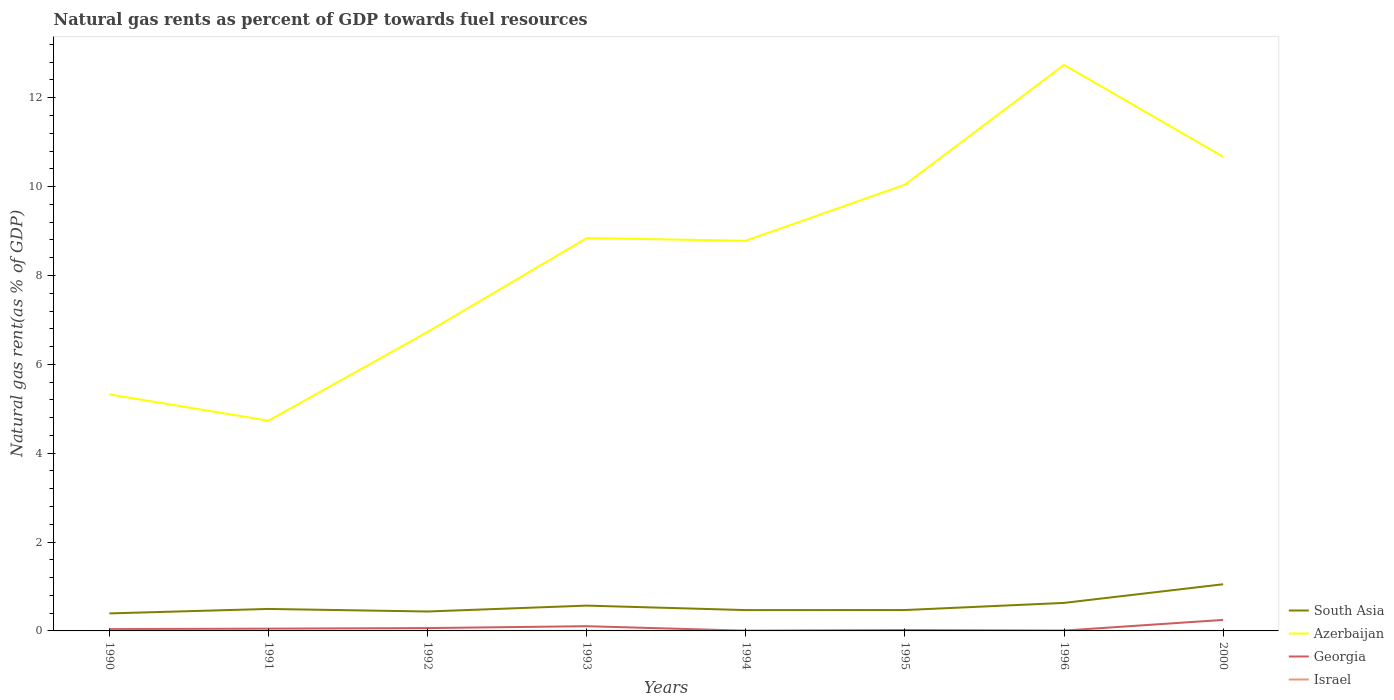How many different coloured lines are there?
Give a very brief answer. 4. Is the number of lines equal to the number of legend labels?
Keep it short and to the point. Yes. Across all years, what is the maximum natural gas rent in Georgia?
Provide a short and direct response. 0.01. In which year was the natural gas rent in Azerbaijan maximum?
Provide a succinct answer. 1991. What is the total natural gas rent in Azerbaijan in the graph?
Provide a short and direct response. -6.01. What is the difference between the highest and the second highest natural gas rent in Azerbaijan?
Ensure brevity in your answer.  8.01. What is the difference between the highest and the lowest natural gas rent in South Asia?
Your answer should be compact. 3. Is the natural gas rent in Georgia strictly greater than the natural gas rent in Azerbaijan over the years?
Offer a very short reply. Yes. How many lines are there?
Offer a terse response. 4. How many years are there in the graph?
Make the answer very short. 8. Where does the legend appear in the graph?
Offer a very short reply. Bottom right. What is the title of the graph?
Your answer should be compact. Natural gas rents as percent of GDP towards fuel resources. Does "Finland" appear as one of the legend labels in the graph?
Your response must be concise. No. What is the label or title of the X-axis?
Ensure brevity in your answer.  Years. What is the label or title of the Y-axis?
Provide a succinct answer. Natural gas rent(as % of GDP). What is the Natural gas rent(as % of GDP) in South Asia in 1990?
Your answer should be compact. 0.39. What is the Natural gas rent(as % of GDP) in Azerbaijan in 1990?
Keep it short and to the point. 5.32. What is the Natural gas rent(as % of GDP) of Georgia in 1990?
Give a very brief answer. 0.04. What is the Natural gas rent(as % of GDP) of Israel in 1990?
Your response must be concise. 0. What is the Natural gas rent(as % of GDP) of South Asia in 1991?
Provide a short and direct response. 0.49. What is the Natural gas rent(as % of GDP) in Azerbaijan in 1991?
Provide a short and direct response. 4.73. What is the Natural gas rent(as % of GDP) of Georgia in 1991?
Offer a very short reply. 0.05. What is the Natural gas rent(as % of GDP) of Israel in 1991?
Provide a short and direct response. 0. What is the Natural gas rent(as % of GDP) in South Asia in 1992?
Give a very brief answer. 0.44. What is the Natural gas rent(as % of GDP) of Azerbaijan in 1992?
Your response must be concise. 6.73. What is the Natural gas rent(as % of GDP) in Georgia in 1992?
Offer a very short reply. 0.06. What is the Natural gas rent(as % of GDP) in Israel in 1992?
Keep it short and to the point. 0. What is the Natural gas rent(as % of GDP) in South Asia in 1993?
Give a very brief answer. 0.57. What is the Natural gas rent(as % of GDP) in Azerbaijan in 1993?
Your answer should be very brief. 8.84. What is the Natural gas rent(as % of GDP) of Georgia in 1993?
Provide a succinct answer. 0.11. What is the Natural gas rent(as % of GDP) in Israel in 1993?
Give a very brief answer. 0. What is the Natural gas rent(as % of GDP) of South Asia in 1994?
Provide a short and direct response. 0.47. What is the Natural gas rent(as % of GDP) of Azerbaijan in 1994?
Provide a short and direct response. 8.78. What is the Natural gas rent(as % of GDP) of Georgia in 1994?
Provide a succinct answer. 0.01. What is the Natural gas rent(as % of GDP) of Israel in 1994?
Provide a short and direct response. 0. What is the Natural gas rent(as % of GDP) in South Asia in 1995?
Your answer should be compact. 0.47. What is the Natural gas rent(as % of GDP) in Azerbaijan in 1995?
Your response must be concise. 10.04. What is the Natural gas rent(as % of GDP) in Georgia in 1995?
Your answer should be compact. 0.02. What is the Natural gas rent(as % of GDP) of Israel in 1995?
Provide a succinct answer. 0. What is the Natural gas rent(as % of GDP) in South Asia in 1996?
Make the answer very short. 0.63. What is the Natural gas rent(as % of GDP) in Azerbaijan in 1996?
Provide a succinct answer. 12.74. What is the Natural gas rent(as % of GDP) in Georgia in 1996?
Make the answer very short. 0.01. What is the Natural gas rent(as % of GDP) of Israel in 1996?
Provide a short and direct response. 0. What is the Natural gas rent(as % of GDP) of South Asia in 2000?
Give a very brief answer. 1.05. What is the Natural gas rent(as % of GDP) in Azerbaijan in 2000?
Ensure brevity in your answer.  10.67. What is the Natural gas rent(as % of GDP) of Georgia in 2000?
Ensure brevity in your answer.  0.25. What is the Natural gas rent(as % of GDP) in Israel in 2000?
Your answer should be very brief. 0. Across all years, what is the maximum Natural gas rent(as % of GDP) of South Asia?
Give a very brief answer. 1.05. Across all years, what is the maximum Natural gas rent(as % of GDP) in Azerbaijan?
Make the answer very short. 12.74. Across all years, what is the maximum Natural gas rent(as % of GDP) of Georgia?
Offer a terse response. 0.25. Across all years, what is the maximum Natural gas rent(as % of GDP) in Israel?
Provide a short and direct response. 0. Across all years, what is the minimum Natural gas rent(as % of GDP) of South Asia?
Offer a terse response. 0.39. Across all years, what is the minimum Natural gas rent(as % of GDP) of Azerbaijan?
Offer a very short reply. 4.73. Across all years, what is the minimum Natural gas rent(as % of GDP) in Georgia?
Give a very brief answer. 0.01. Across all years, what is the minimum Natural gas rent(as % of GDP) of Israel?
Ensure brevity in your answer.  0. What is the total Natural gas rent(as % of GDP) in South Asia in the graph?
Make the answer very short. 4.52. What is the total Natural gas rent(as % of GDP) of Azerbaijan in the graph?
Ensure brevity in your answer.  67.86. What is the total Natural gas rent(as % of GDP) in Georgia in the graph?
Provide a succinct answer. 0.54. What is the total Natural gas rent(as % of GDP) in Israel in the graph?
Keep it short and to the point. 0.02. What is the difference between the Natural gas rent(as % of GDP) of South Asia in 1990 and that in 1991?
Offer a very short reply. -0.1. What is the difference between the Natural gas rent(as % of GDP) in Azerbaijan in 1990 and that in 1991?
Your answer should be compact. 0.59. What is the difference between the Natural gas rent(as % of GDP) in Georgia in 1990 and that in 1991?
Give a very brief answer. -0.01. What is the difference between the Natural gas rent(as % of GDP) in Israel in 1990 and that in 1991?
Keep it short and to the point. 0. What is the difference between the Natural gas rent(as % of GDP) of South Asia in 1990 and that in 1992?
Your answer should be very brief. -0.04. What is the difference between the Natural gas rent(as % of GDP) of Azerbaijan in 1990 and that in 1992?
Give a very brief answer. -1.41. What is the difference between the Natural gas rent(as % of GDP) in Georgia in 1990 and that in 1992?
Provide a succinct answer. -0.02. What is the difference between the Natural gas rent(as % of GDP) in Israel in 1990 and that in 1992?
Provide a short and direct response. 0. What is the difference between the Natural gas rent(as % of GDP) of South Asia in 1990 and that in 1993?
Give a very brief answer. -0.18. What is the difference between the Natural gas rent(as % of GDP) in Azerbaijan in 1990 and that in 1993?
Provide a short and direct response. -3.52. What is the difference between the Natural gas rent(as % of GDP) in Georgia in 1990 and that in 1993?
Offer a very short reply. -0.07. What is the difference between the Natural gas rent(as % of GDP) of Israel in 1990 and that in 1993?
Your answer should be very brief. 0. What is the difference between the Natural gas rent(as % of GDP) of South Asia in 1990 and that in 1994?
Your answer should be very brief. -0.07. What is the difference between the Natural gas rent(as % of GDP) of Azerbaijan in 1990 and that in 1994?
Provide a succinct answer. -3.46. What is the difference between the Natural gas rent(as % of GDP) of Georgia in 1990 and that in 1994?
Your response must be concise. 0.04. What is the difference between the Natural gas rent(as % of GDP) in Israel in 1990 and that in 1994?
Give a very brief answer. 0. What is the difference between the Natural gas rent(as % of GDP) in South Asia in 1990 and that in 1995?
Your response must be concise. -0.08. What is the difference between the Natural gas rent(as % of GDP) in Azerbaijan in 1990 and that in 1995?
Your answer should be very brief. -4.72. What is the difference between the Natural gas rent(as % of GDP) of Georgia in 1990 and that in 1995?
Provide a succinct answer. 0.02. What is the difference between the Natural gas rent(as % of GDP) in Israel in 1990 and that in 1995?
Your answer should be very brief. 0. What is the difference between the Natural gas rent(as % of GDP) in South Asia in 1990 and that in 1996?
Give a very brief answer. -0.24. What is the difference between the Natural gas rent(as % of GDP) in Azerbaijan in 1990 and that in 1996?
Your answer should be compact. -7.42. What is the difference between the Natural gas rent(as % of GDP) in Georgia in 1990 and that in 1996?
Provide a short and direct response. 0.03. What is the difference between the Natural gas rent(as % of GDP) in Israel in 1990 and that in 1996?
Ensure brevity in your answer.  0. What is the difference between the Natural gas rent(as % of GDP) in South Asia in 1990 and that in 2000?
Make the answer very short. -0.66. What is the difference between the Natural gas rent(as % of GDP) of Azerbaijan in 1990 and that in 2000?
Offer a very short reply. -5.35. What is the difference between the Natural gas rent(as % of GDP) in Georgia in 1990 and that in 2000?
Keep it short and to the point. -0.21. What is the difference between the Natural gas rent(as % of GDP) in Israel in 1990 and that in 2000?
Your answer should be compact. 0. What is the difference between the Natural gas rent(as % of GDP) in South Asia in 1991 and that in 1992?
Ensure brevity in your answer.  0.06. What is the difference between the Natural gas rent(as % of GDP) of Azerbaijan in 1991 and that in 1992?
Ensure brevity in your answer.  -2. What is the difference between the Natural gas rent(as % of GDP) of Georgia in 1991 and that in 1992?
Your response must be concise. -0.01. What is the difference between the Natural gas rent(as % of GDP) of Israel in 1991 and that in 1992?
Your response must be concise. 0. What is the difference between the Natural gas rent(as % of GDP) of South Asia in 1991 and that in 1993?
Your answer should be compact. -0.07. What is the difference between the Natural gas rent(as % of GDP) in Azerbaijan in 1991 and that in 1993?
Offer a terse response. -4.11. What is the difference between the Natural gas rent(as % of GDP) of Georgia in 1991 and that in 1993?
Offer a terse response. -0.06. What is the difference between the Natural gas rent(as % of GDP) of South Asia in 1991 and that in 1994?
Provide a short and direct response. 0.03. What is the difference between the Natural gas rent(as % of GDP) in Azerbaijan in 1991 and that in 1994?
Provide a succinct answer. -4.05. What is the difference between the Natural gas rent(as % of GDP) in Georgia in 1991 and that in 1994?
Provide a succinct answer. 0.05. What is the difference between the Natural gas rent(as % of GDP) in Israel in 1991 and that in 1994?
Offer a terse response. 0. What is the difference between the Natural gas rent(as % of GDP) in South Asia in 1991 and that in 1995?
Your answer should be compact. 0.02. What is the difference between the Natural gas rent(as % of GDP) of Azerbaijan in 1991 and that in 1995?
Provide a succinct answer. -5.31. What is the difference between the Natural gas rent(as % of GDP) of Georgia in 1991 and that in 1995?
Keep it short and to the point. 0.03. What is the difference between the Natural gas rent(as % of GDP) of Israel in 1991 and that in 1995?
Provide a succinct answer. 0. What is the difference between the Natural gas rent(as % of GDP) of South Asia in 1991 and that in 1996?
Your answer should be very brief. -0.14. What is the difference between the Natural gas rent(as % of GDP) in Azerbaijan in 1991 and that in 1996?
Your answer should be very brief. -8.01. What is the difference between the Natural gas rent(as % of GDP) in Georgia in 1991 and that in 1996?
Ensure brevity in your answer.  0.04. What is the difference between the Natural gas rent(as % of GDP) of Israel in 1991 and that in 1996?
Offer a very short reply. 0. What is the difference between the Natural gas rent(as % of GDP) in South Asia in 1991 and that in 2000?
Provide a succinct answer. -0.56. What is the difference between the Natural gas rent(as % of GDP) of Azerbaijan in 1991 and that in 2000?
Make the answer very short. -5.94. What is the difference between the Natural gas rent(as % of GDP) in Georgia in 1991 and that in 2000?
Your answer should be compact. -0.2. What is the difference between the Natural gas rent(as % of GDP) of Israel in 1991 and that in 2000?
Give a very brief answer. 0. What is the difference between the Natural gas rent(as % of GDP) in South Asia in 1992 and that in 1993?
Offer a very short reply. -0.13. What is the difference between the Natural gas rent(as % of GDP) of Azerbaijan in 1992 and that in 1993?
Keep it short and to the point. -2.11. What is the difference between the Natural gas rent(as % of GDP) of Georgia in 1992 and that in 1993?
Keep it short and to the point. -0.04. What is the difference between the Natural gas rent(as % of GDP) in Israel in 1992 and that in 1993?
Your answer should be very brief. -0. What is the difference between the Natural gas rent(as % of GDP) in South Asia in 1992 and that in 1994?
Ensure brevity in your answer.  -0.03. What is the difference between the Natural gas rent(as % of GDP) of Azerbaijan in 1992 and that in 1994?
Provide a short and direct response. -2.05. What is the difference between the Natural gas rent(as % of GDP) of Georgia in 1992 and that in 1994?
Make the answer very short. 0.06. What is the difference between the Natural gas rent(as % of GDP) of South Asia in 1992 and that in 1995?
Your response must be concise. -0.03. What is the difference between the Natural gas rent(as % of GDP) in Azerbaijan in 1992 and that in 1995?
Offer a very short reply. -3.31. What is the difference between the Natural gas rent(as % of GDP) of Georgia in 1992 and that in 1995?
Ensure brevity in your answer.  0.04. What is the difference between the Natural gas rent(as % of GDP) in Israel in 1992 and that in 1995?
Offer a very short reply. 0. What is the difference between the Natural gas rent(as % of GDP) of South Asia in 1992 and that in 1996?
Make the answer very short. -0.19. What is the difference between the Natural gas rent(as % of GDP) in Azerbaijan in 1992 and that in 1996?
Provide a short and direct response. -6.01. What is the difference between the Natural gas rent(as % of GDP) in Georgia in 1992 and that in 1996?
Provide a succinct answer. 0.06. What is the difference between the Natural gas rent(as % of GDP) in South Asia in 1992 and that in 2000?
Your answer should be very brief. -0.61. What is the difference between the Natural gas rent(as % of GDP) in Azerbaijan in 1992 and that in 2000?
Give a very brief answer. -3.94. What is the difference between the Natural gas rent(as % of GDP) of Georgia in 1992 and that in 2000?
Keep it short and to the point. -0.18. What is the difference between the Natural gas rent(as % of GDP) in Israel in 1992 and that in 2000?
Offer a terse response. 0. What is the difference between the Natural gas rent(as % of GDP) of South Asia in 1993 and that in 1994?
Provide a short and direct response. 0.1. What is the difference between the Natural gas rent(as % of GDP) of Azerbaijan in 1993 and that in 1994?
Provide a short and direct response. 0.06. What is the difference between the Natural gas rent(as % of GDP) in Georgia in 1993 and that in 1994?
Make the answer very short. 0.1. What is the difference between the Natural gas rent(as % of GDP) of Israel in 1993 and that in 1994?
Provide a short and direct response. 0. What is the difference between the Natural gas rent(as % of GDP) of South Asia in 1993 and that in 1995?
Ensure brevity in your answer.  0.1. What is the difference between the Natural gas rent(as % of GDP) of Azerbaijan in 1993 and that in 1995?
Offer a terse response. -1.2. What is the difference between the Natural gas rent(as % of GDP) in Georgia in 1993 and that in 1995?
Your response must be concise. 0.09. What is the difference between the Natural gas rent(as % of GDP) in Israel in 1993 and that in 1995?
Your answer should be compact. 0. What is the difference between the Natural gas rent(as % of GDP) of South Asia in 1993 and that in 1996?
Offer a very short reply. -0.06. What is the difference between the Natural gas rent(as % of GDP) in Azerbaijan in 1993 and that in 1996?
Offer a terse response. -3.9. What is the difference between the Natural gas rent(as % of GDP) of Georgia in 1993 and that in 1996?
Provide a succinct answer. 0.1. What is the difference between the Natural gas rent(as % of GDP) of Israel in 1993 and that in 1996?
Offer a terse response. 0. What is the difference between the Natural gas rent(as % of GDP) in South Asia in 1993 and that in 2000?
Ensure brevity in your answer.  -0.48. What is the difference between the Natural gas rent(as % of GDP) of Azerbaijan in 1993 and that in 2000?
Offer a terse response. -1.83. What is the difference between the Natural gas rent(as % of GDP) in Georgia in 1993 and that in 2000?
Make the answer very short. -0.14. What is the difference between the Natural gas rent(as % of GDP) of Israel in 1993 and that in 2000?
Give a very brief answer. 0. What is the difference between the Natural gas rent(as % of GDP) of South Asia in 1994 and that in 1995?
Your answer should be very brief. -0. What is the difference between the Natural gas rent(as % of GDP) in Azerbaijan in 1994 and that in 1995?
Make the answer very short. -1.26. What is the difference between the Natural gas rent(as % of GDP) of Georgia in 1994 and that in 1995?
Your response must be concise. -0.01. What is the difference between the Natural gas rent(as % of GDP) in South Asia in 1994 and that in 1996?
Give a very brief answer. -0.16. What is the difference between the Natural gas rent(as % of GDP) in Azerbaijan in 1994 and that in 1996?
Give a very brief answer. -3.96. What is the difference between the Natural gas rent(as % of GDP) of Georgia in 1994 and that in 1996?
Provide a succinct answer. -0. What is the difference between the Natural gas rent(as % of GDP) of Israel in 1994 and that in 1996?
Give a very brief answer. 0. What is the difference between the Natural gas rent(as % of GDP) of South Asia in 1994 and that in 2000?
Make the answer very short. -0.58. What is the difference between the Natural gas rent(as % of GDP) in Azerbaijan in 1994 and that in 2000?
Your answer should be compact. -1.89. What is the difference between the Natural gas rent(as % of GDP) in Georgia in 1994 and that in 2000?
Make the answer very short. -0.24. What is the difference between the Natural gas rent(as % of GDP) in Israel in 1994 and that in 2000?
Keep it short and to the point. 0. What is the difference between the Natural gas rent(as % of GDP) of South Asia in 1995 and that in 1996?
Your answer should be very brief. -0.16. What is the difference between the Natural gas rent(as % of GDP) in Azerbaijan in 1995 and that in 1996?
Provide a short and direct response. -2.7. What is the difference between the Natural gas rent(as % of GDP) in Georgia in 1995 and that in 1996?
Give a very brief answer. 0.01. What is the difference between the Natural gas rent(as % of GDP) of South Asia in 1995 and that in 2000?
Provide a succinct answer. -0.58. What is the difference between the Natural gas rent(as % of GDP) in Azerbaijan in 1995 and that in 2000?
Your answer should be very brief. -0.63. What is the difference between the Natural gas rent(as % of GDP) in Georgia in 1995 and that in 2000?
Keep it short and to the point. -0.23. What is the difference between the Natural gas rent(as % of GDP) of South Asia in 1996 and that in 2000?
Make the answer very short. -0.42. What is the difference between the Natural gas rent(as % of GDP) in Azerbaijan in 1996 and that in 2000?
Provide a short and direct response. 2.07. What is the difference between the Natural gas rent(as % of GDP) in Georgia in 1996 and that in 2000?
Provide a short and direct response. -0.24. What is the difference between the Natural gas rent(as % of GDP) of South Asia in 1990 and the Natural gas rent(as % of GDP) of Azerbaijan in 1991?
Your response must be concise. -4.34. What is the difference between the Natural gas rent(as % of GDP) in South Asia in 1990 and the Natural gas rent(as % of GDP) in Georgia in 1991?
Ensure brevity in your answer.  0.34. What is the difference between the Natural gas rent(as % of GDP) in South Asia in 1990 and the Natural gas rent(as % of GDP) in Israel in 1991?
Make the answer very short. 0.39. What is the difference between the Natural gas rent(as % of GDP) of Azerbaijan in 1990 and the Natural gas rent(as % of GDP) of Georgia in 1991?
Give a very brief answer. 5.27. What is the difference between the Natural gas rent(as % of GDP) of Azerbaijan in 1990 and the Natural gas rent(as % of GDP) of Israel in 1991?
Provide a succinct answer. 5.32. What is the difference between the Natural gas rent(as % of GDP) in Georgia in 1990 and the Natural gas rent(as % of GDP) in Israel in 1991?
Offer a terse response. 0.04. What is the difference between the Natural gas rent(as % of GDP) of South Asia in 1990 and the Natural gas rent(as % of GDP) of Azerbaijan in 1992?
Your answer should be compact. -6.34. What is the difference between the Natural gas rent(as % of GDP) in South Asia in 1990 and the Natural gas rent(as % of GDP) in Georgia in 1992?
Keep it short and to the point. 0.33. What is the difference between the Natural gas rent(as % of GDP) of South Asia in 1990 and the Natural gas rent(as % of GDP) of Israel in 1992?
Provide a short and direct response. 0.39. What is the difference between the Natural gas rent(as % of GDP) of Azerbaijan in 1990 and the Natural gas rent(as % of GDP) of Georgia in 1992?
Make the answer very short. 5.26. What is the difference between the Natural gas rent(as % of GDP) of Azerbaijan in 1990 and the Natural gas rent(as % of GDP) of Israel in 1992?
Your response must be concise. 5.32. What is the difference between the Natural gas rent(as % of GDP) of Georgia in 1990 and the Natural gas rent(as % of GDP) of Israel in 1992?
Ensure brevity in your answer.  0.04. What is the difference between the Natural gas rent(as % of GDP) of South Asia in 1990 and the Natural gas rent(as % of GDP) of Azerbaijan in 1993?
Your response must be concise. -8.45. What is the difference between the Natural gas rent(as % of GDP) in South Asia in 1990 and the Natural gas rent(as % of GDP) in Georgia in 1993?
Provide a short and direct response. 0.29. What is the difference between the Natural gas rent(as % of GDP) of South Asia in 1990 and the Natural gas rent(as % of GDP) of Israel in 1993?
Offer a terse response. 0.39. What is the difference between the Natural gas rent(as % of GDP) of Azerbaijan in 1990 and the Natural gas rent(as % of GDP) of Georgia in 1993?
Your response must be concise. 5.22. What is the difference between the Natural gas rent(as % of GDP) in Azerbaijan in 1990 and the Natural gas rent(as % of GDP) in Israel in 1993?
Provide a succinct answer. 5.32. What is the difference between the Natural gas rent(as % of GDP) in Georgia in 1990 and the Natural gas rent(as % of GDP) in Israel in 1993?
Your response must be concise. 0.04. What is the difference between the Natural gas rent(as % of GDP) in South Asia in 1990 and the Natural gas rent(as % of GDP) in Azerbaijan in 1994?
Your answer should be compact. -8.39. What is the difference between the Natural gas rent(as % of GDP) of South Asia in 1990 and the Natural gas rent(as % of GDP) of Georgia in 1994?
Your answer should be compact. 0.39. What is the difference between the Natural gas rent(as % of GDP) in South Asia in 1990 and the Natural gas rent(as % of GDP) in Israel in 1994?
Ensure brevity in your answer.  0.39. What is the difference between the Natural gas rent(as % of GDP) of Azerbaijan in 1990 and the Natural gas rent(as % of GDP) of Georgia in 1994?
Ensure brevity in your answer.  5.32. What is the difference between the Natural gas rent(as % of GDP) of Azerbaijan in 1990 and the Natural gas rent(as % of GDP) of Israel in 1994?
Your response must be concise. 5.32. What is the difference between the Natural gas rent(as % of GDP) in Georgia in 1990 and the Natural gas rent(as % of GDP) in Israel in 1994?
Provide a succinct answer. 0.04. What is the difference between the Natural gas rent(as % of GDP) of South Asia in 1990 and the Natural gas rent(as % of GDP) of Azerbaijan in 1995?
Provide a short and direct response. -9.65. What is the difference between the Natural gas rent(as % of GDP) of South Asia in 1990 and the Natural gas rent(as % of GDP) of Georgia in 1995?
Ensure brevity in your answer.  0.37. What is the difference between the Natural gas rent(as % of GDP) of South Asia in 1990 and the Natural gas rent(as % of GDP) of Israel in 1995?
Your answer should be compact. 0.39. What is the difference between the Natural gas rent(as % of GDP) in Azerbaijan in 1990 and the Natural gas rent(as % of GDP) in Georgia in 1995?
Give a very brief answer. 5.3. What is the difference between the Natural gas rent(as % of GDP) in Azerbaijan in 1990 and the Natural gas rent(as % of GDP) in Israel in 1995?
Provide a short and direct response. 5.32. What is the difference between the Natural gas rent(as % of GDP) of Georgia in 1990 and the Natural gas rent(as % of GDP) of Israel in 1995?
Provide a short and direct response. 0.04. What is the difference between the Natural gas rent(as % of GDP) in South Asia in 1990 and the Natural gas rent(as % of GDP) in Azerbaijan in 1996?
Ensure brevity in your answer.  -12.35. What is the difference between the Natural gas rent(as % of GDP) of South Asia in 1990 and the Natural gas rent(as % of GDP) of Georgia in 1996?
Offer a terse response. 0.39. What is the difference between the Natural gas rent(as % of GDP) of South Asia in 1990 and the Natural gas rent(as % of GDP) of Israel in 1996?
Ensure brevity in your answer.  0.39. What is the difference between the Natural gas rent(as % of GDP) in Azerbaijan in 1990 and the Natural gas rent(as % of GDP) in Georgia in 1996?
Keep it short and to the point. 5.32. What is the difference between the Natural gas rent(as % of GDP) in Azerbaijan in 1990 and the Natural gas rent(as % of GDP) in Israel in 1996?
Ensure brevity in your answer.  5.32. What is the difference between the Natural gas rent(as % of GDP) of Georgia in 1990 and the Natural gas rent(as % of GDP) of Israel in 1996?
Your answer should be very brief. 0.04. What is the difference between the Natural gas rent(as % of GDP) of South Asia in 1990 and the Natural gas rent(as % of GDP) of Azerbaijan in 2000?
Offer a terse response. -10.28. What is the difference between the Natural gas rent(as % of GDP) of South Asia in 1990 and the Natural gas rent(as % of GDP) of Georgia in 2000?
Your answer should be very brief. 0.15. What is the difference between the Natural gas rent(as % of GDP) of South Asia in 1990 and the Natural gas rent(as % of GDP) of Israel in 2000?
Your answer should be very brief. 0.39. What is the difference between the Natural gas rent(as % of GDP) in Azerbaijan in 1990 and the Natural gas rent(as % of GDP) in Georgia in 2000?
Give a very brief answer. 5.08. What is the difference between the Natural gas rent(as % of GDP) of Azerbaijan in 1990 and the Natural gas rent(as % of GDP) of Israel in 2000?
Make the answer very short. 5.32. What is the difference between the Natural gas rent(as % of GDP) of Georgia in 1990 and the Natural gas rent(as % of GDP) of Israel in 2000?
Your answer should be compact. 0.04. What is the difference between the Natural gas rent(as % of GDP) of South Asia in 1991 and the Natural gas rent(as % of GDP) of Azerbaijan in 1992?
Offer a very short reply. -6.24. What is the difference between the Natural gas rent(as % of GDP) in South Asia in 1991 and the Natural gas rent(as % of GDP) in Georgia in 1992?
Provide a succinct answer. 0.43. What is the difference between the Natural gas rent(as % of GDP) of South Asia in 1991 and the Natural gas rent(as % of GDP) of Israel in 1992?
Give a very brief answer. 0.49. What is the difference between the Natural gas rent(as % of GDP) in Azerbaijan in 1991 and the Natural gas rent(as % of GDP) in Georgia in 1992?
Your response must be concise. 4.67. What is the difference between the Natural gas rent(as % of GDP) of Azerbaijan in 1991 and the Natural gas rent(as % of GDP) of Israel in 1992?
Your response must be concise. 4.73. What is the difference between the Natural gas rent(as % of GDP) of Georgia in 1991 and the Natural gas rent(as % of GDP) of Israel in 1992?
Give a very brief answer. 0.05. What is the difference between the Natural gas rent(as % of GDP) in South Asia in 1991 and the Natural gas rent(as % of GDP) in Azerbaijan in 1993?
Your response must be concise. -8.35. What is the difference between the Natural gas rent(as % of GDP) of South Asia in 1991 and the Natural gas rent(as % of GDP) of Georgia in 1993?
Make the answer very short. 0.39. What is the difference between the Natural gas rent(as % of GDP) of South Asia in 1991 and the Natural gas rent(as % of GDP) of Israel in 1993?
Your answer should be very brief. 0.49. What is the difference between the Natural gas rent(as % of GDP) in Azerbaijan in 1991 and the Natural gas rent(as % of GDP) in Georgia in 1993?
Your response must be concise. 4.63. What is the difference between the Natural gas rent(as % of GDP) in Azerbaijan in 1991 and the Natural gas rent(as % of GDP) in Israel in 1993?
Make the answer very short. 4.73. What is the difference between the Natural gas rent(as % of GDP) in Georgia in 1991 and the Natural gas rent(as % of GDP) in Israel in 1993?
Keep it short and to the point. 0.05. What is the difference between the Natural gas rent(as % of GDP) in South Asia in 1991 and the Natural gas rent(as % of GDP) in Azerbaijan in 1994?
Offer a very short reply. -8.29. What is the difference between the Natural gas rent(as % of GDP) in South Asia in 1991 and the Natural gas rent(as % of GDP) in Georgia in 1994?
Offer a terse response. 0.49. What is the difference between the Natural gas rent(as % of GDP) of South Asia in 1991 and the Natural gas rent(as % of GDP) of Israel in 1994?
Provide a short and direct response. 0.49. What is the difference between the Natural gas rent(as % of GDP) in Azerbaijan in 1991 and the Natural gas rent(as % of GDP) in Georgia in 1994?
Ensure brevity in your answer.  4.73. What is the difference between the Natural gas rent(as % of GDP) in Azerbaijan in 1991 and the Natural gas rent(as % of GDP) in Israel in 1994?
Provide a succinct answer. 4.73. What is the difference between the Natural gas rent(as % of GDP) in Georgia in 1991 and the Natural gas rent(as % of GDP) in Israel in 1994?
Offer a very short reply. 0.05. What is the difference between the Natural gas rent(as % of GDP) of South Asia in 1991 and the Natural gas rent(as % of GDP) of Azerbaijan in 1995?
Make the answer very short. -9.55. What is the difference between the Natural gas rent(as % of GDP) of South Asia in 1991 and the Natural gas rent(as % of GDP) of Georgia in 1995?
Offer a terse response. 0.47. What is the difference between the Natural gas rent(as % of GDP) of South Asia in 1991 and the Natural gas rent(as % of GDP) of Israel in 1995?
Ensure brevity in your answer.  0.49. What is the difference between the Natural gas rent(as % of GDP) in Azerbaijan in 1991 and the Natural gas rent(as % of GDP) in Georgia in 1995?
Keep it short and to the point. 4.71. What is the difference between the Natural gas rent(as % of GDP) in Azerbaijan in 1991 and the Natural gas rent(as % of GDP) in Israel in 1995?
Provide a short and direct response. 4.73. What is the difference between the Natural gas rent(as % of GDP) in Georgia in 1991 and the Natural gas rent(as % of GDP) in Israel in 1995?
Give a very brief answer. 0.05. What is the difference between the Natural gas rent(as % of GDP) in South Asia in 1991 and the Natural gas rent(as % of GDP) in Azerbaijan in 1996?
Ensure brevity in your answer.  -12.25. What is the difference between the Natural gas rent(as % of GDP) in South Asia in 1991 and the Natural gas rent(as % of GDP) in Georgia in 1996?
Give a very brief answer. 0.49. What is the difference between the Natural gas rent(as % of GDP) in South Asia in 1991 and the Natural gas rent(as % of GDP) in Israel in 1996?
Offer a terse response. 0.49. What is the difference between the Natural gas rent(as % of GDP) in Azerbaijan in 1991 and the Natural gas rent(as % of GDP) in Georgia in 1996?
Ensure brevity in your answer.  4.72. What is the difference between the Natural gas rent(as % of GDP) of Azerbaijan in 1991 and the Natural gas rent(as % of GDP) of Israel in 1996?
Your answer should be very brief. 4.73. What is the difference between the Natural gas rent(as % of GDP) of Georgia in 1991 and the Natural gas rent(as % of GDP) of Israel in 1996?
Give a very brief answer. 0.05. What is the difference between the Natural gas rent(as % of GDP) in South Asia in 1991 and the Natural gas rent(as % of GDP) in Azerbaijan in 2000?
Your response must be concise. -10.18. What is the difference between the Natural gas rent(as % of GDP) of South Asia in 1991 and the Natural gas rent(as % of GDP) of Georgia in 2000?
Ensure brevity in your answer.  0.25. What is the difference between the Natural gas rent(as % of GDP) in South Asia in 1991 and the Natural gas rent(as % of GDP) in Israel in 2000?
Keep it short and to the point. 0.49. What is the difference between the Natural gas rent(as % of GDP) of Azerbaijan in 1991 and the Natural gas rent(as % of GDP) of Georgia in 2000?
Your answer should be very brief. 4.48. What is the difference between the Natural gas rent(as % of GDP) of Azerbaijan in 1991 and the Natural gas rent(as % of GDP) of Israel in 2000?
Provide a succinct answer. 4.73. What is the difference between the Natural gas rent(as % of GDP) of Georgia in 1991 and the Natural gas rent(as % of GDP) of Israel in 2000?
Your answer should be very brief. 0.05. What is the difference between the Natural gas rent(as % of GDP) in South Asia in 1992 and the Natural gas rent(as % of GDP) in Azerbaijan in 1993?
Ensure brevity in your answer.  -8.4. What is the difference between the Natural gas rent(as % of GDP) in South Asia in 1992 and the Natural gas rent(as % of GDP) in Georgia in 1993?
Offer a terse response. 0.33. What is the difference between the Natural gas rent(as % of GDP) of South Asia in 1992 and the Natural gas rent(as % of GDP) of Israel in 1993?
Give a very brief answer. 0.43. What is the difference between the Natural gas rent(as % of GDP) of Azerbaijan in 1992 and the Natural gas rent(as % of GDP) of Georgia in 1993?
Offer a terse response. 6.62. What is the difference between the Natural gas rent(as % of GDP) in Azerbaijan in 1992 and the Natural gas rent(as % of GDP) in Israel in 1993?
Your answer should be very brief. 6.73. What is the difference between the Natural gas rent(as % of GDP) in Georgia in 1992 and the Natural gas rent(as % of GDP) in Israel in 1993?
Your answer should be very brief. 0.06. What is the difference between the Natural gas rent(as % of GDP) of South Asia in 1992 and the Natural gas rent(as % of GDP) of Azerbaijan in 1994?
Provide a succinct answer. -8.35. What is the difference between the Natural gas rent(as % of GDP) of South Asia in 1992 and the Natural gas rent(as % of GDP) of Georgia in 1994?
Make the answer very short. 0.43. What is the difference between the Natural gas rent(as % of GDP) of South Asia in 1992 and the Natural gas rent(as % of GDP) of Israel in 1994?
Provide a short and direct response. 0.44. What is the difference between the Natural gas rent(as % of GDP) in Azerbaijan in 1992 and the Natural gas rent(as % of GDP) in Georgia in 1994?
Provide a succinct answer. 6.73. What is the difference between the Natural gas rent(as % of GDP) in Azerbaijan in 1992 and the Natural gas rent(as % of GDP) in Israel in 1994?
Offer a very short reply. 6.73. What is the difference between the Natural gas rent(as % of GDP) of Georgia in 1992 and the Natural gas rent(as % of GDP) of Israel in 1994?
Offer a terse response. 0.06. What is the difference between the Natural gas rent(as % of GDP) of South Asia in 1992 and the Natural gas rent(as % of GDP) of Azerbaijan in 1995?
Offer a very short reply. -9.61. What is the difference between the Natural gas rent(as % of GDP) of South Asia in 1992 and the Natural gas rent(as % of GDP) of Georgia in 1995?
Offer a very short reply. 0.42. What is the difference between the Natural gas rent(as % of GDP) in South Asia in 1992 and the Natural gas rent(as % of GDP) in Israel in 1995?
Give a very brief answer. 0.44. What is the difference between the Natural gas rent(as % of GDP) of Azerbaijan in 1992 and the Natural gas rent(as % of GDP) of Georgia in 1995?
Your answer should be very brief. 6.71. What is the difference between the Natural gas rent(as % of GDP) in Azerbaijan in 1992 and the Natural gas rent(as % of GDP) in Israel in 1995?
Offer a terse response. 6.73. What is the difference between the Natural gas rent(as % of GDP) in Georgia in 1992 and the Natural gas rent(as % of GDP) in Israel in 1995?
Your answer should be compact. 0.06. What is the difference between the Natural gas rent(as % of GDP) of South Asia in 1992 and the Natural gas rent(as % of GDP) of Azerbaijan in 1996?
Ensure brevity in your answer.  -12.3. What is the difference between the Natural gas rent(as % of GDP) of South Asia in 1992 and the Natural gas rent(as % of GDP) of Georgia in 1996?
Your answer should be compact. 0.43. What is the difference between the Natural gas rent(as % of GDP) in South Asia in 1992 and the Natural gas rent(as % of GDP) in Israel in 1996?
Your answer should be very brief. 0.44. What is the difference between the Natural gas rent(as % of GDP) in Azerbaijan in 1992 and the Natural gas rent(as % of GDP) in Georgia in 1996?
Your answer should be very brief. 6.72. What is the difference between the Natural gas rent(as % of GDP) of Azerbaijan in 1992 and the Natural gas rent(as % of GDP) of Israel in 1996?
Offer a terse response. 6.73. What is the difference between the Natural gas rent(as % of GDP) of Georgia in 1992 and the Natural gas rent(as % of GDP) of Israel in 1996?
Provide a short and direct response. 0.06. What is the difference between the Natural gas rent(as % of GDP) of South Asia in 1992 and the Natural gas rent(as % of GDP) of Azerbaijan in 2000?
Your answer should be compact. -10.23. What is the difference between the Natural gas rent(as % of GDP) of South Asia in 1992 and the Natural gas rent(as % of GDP) of Georgia in 2000?
Make the answer very short. 0.19. What is the difference between the Natural gas rent(as % of GDP) in South Asia in 1992 and the Natural gas rent(as % of GDP) in Israel in 2000?
Your answer should be compact. 0.44. What is the difference between the Natural gas rent(as % of GDP) in Azerbaijan in 1992 and the Natural gas rent(as % of GDP) in Georgia in 2000?
Your response must be concise. 6.48. What is the difference between the Natural gas rent(as % of GDP) of Azerbaijan in 1992 and the Natural gas rent(as % of GDP) of Israel in 2000?
Provide a succinct answer. 6.73. What is the difference between the Natural gas rent(as % of GDP) of Georgia in 1992 and the Natural gas rent(as % of GDP) of Israel in 2000?
Keep it short and to the point. 0.06. What is the difference between the Natural gas rent(as % of GDP) in South Asia in 1993 and the Natural gas rent(as % of GDP) in Azerbaijan in 1994?
Your answer should be very brief. -8.21. What is the difference between the Natural gas rent(as % of GDP) of South Asia in 1993 and the Natural gas rent(as % of GDP) of Georgia in 1994?
Provide a short and direct response. 0.56. What is the difference between the Natural gas rent(as % of GDP) of South Asia in 1993 and the Natural gas rent(as % of GDP) of Israel in 1994?
Make the answer very short. 0.57. What is the difference between the Natural gas rent(as % of GDP) in Azerbaijan in 1993 and the Natural gas rent(as % of GDP) in Georgia in 1994?
Offer a very short reply. 8.84. What is the difference between the Natural gas rent(as % of GDP) of Azerbaijan in 1993 and the Natural gas rent(as % of GDP) of Israel in 1994?
Your answer should be very brief. 8.84. What is the difference between the Natural gas rent(as % of GDP) in Georgia in 1993 and the Natural gas rent(as % of GDP) in Israel in 1994?
Make the answer very short. 0.1. What is the difference between the Natural gas rent(as % of GDP) of South Asia in 1993 and the Natural gas rent(as % of GDP) of Azerbaijan in 1995?
Offer a terse response. -9.47. What is the difference between the Natural gas rent(as % of GDP) of South Asia in 1993 and the Natural gas rent(as % of GDP) of Georgia in 1995?
Ensure brevity in your answer.  0.55. What is the difference between the Natural gas rent(as % of GDP) in South Asia in 1993 and the Natural gas rent(as % of GDP) in Israel in 1995?
Make the answer very short. 0.57. What is the difference between the Natural gas rent(as % of GDP) in Azerbaijan in 1993 and the Natural gas rent(as % of GDP) in Georgia in 1995?
Ensure brevity in your answer.  8.82. What is the difference between the Natural gas rent(as % of GDP) in Azerbaijan in 1993 and the Natural gas rent(as % of GDP) in Israel in 1995?
Offer a very short reply. 8.84. What is the difference between the Natural gas rent(as % of GDP) of Georgia in 1993 and the Natural gas rent(as % of GDP) of Israel in 1995?
Provide a short and direct response. 0.1. What is the difference between the Natural gas rent(as % of GDP) in South Asia in 1993 and the Natural gas rent(as % of GDP) in Azerbaijan in 1996?
Give a very brief answer. -12.17. What is the difference between the Natural gas rent(as % of GDP) in South Asia in 1993 and the Natural gas rent(as % of GDP) in Georgia in 1996?
Make the answer very short. 0.56. What is the difference between the Natural gas rent(as % of GDP) of South Asia in 1993 and the Natural gas rent(as % of GDP) of Israel in 1996?
Keep it short and to the point. 0.57. What is the difference between the Natural gas rent(as % of GDP) in Azerbaijan in 1993 and the Natural gas rent(as % of GDP) in Georgia in 1996?
Offer a terse response. 8.83. What is the difference between the Natural gas rent(as % of GDP) of Azerbaijan in 1993 and the Natural gas rent(as % of GDP) of Israel in 1996?
Your answer should be very brief. 8.84. What is the difference between the Natural gas rent(as % of GDP) in Georgia in 1993 and the Natural gas rent(as % of GDP) in Israel in 1996?
Provide a short and direct response. 0.11. What is the difference between the Natural gas rent(as % of GDP) in South Asia in 1993 and the Natural gas rent(as % of GDP) in Azerbaijan in 2000?
Provide a short and direct response. -10.1. What is the difference between the Natural gas rent(as % of GDP) in South Asia in 1993 and the Natural gas rent(as % of GDP) in Georgia in 2000?
Offer a very short reply. 0.32. What is the difference between the Natural gas rent(as % of GDP) of South Asia in 1993 and the Natural gas rent(as % of GDP) of Israel in 2000?
Make the answer very short. 0.57. What is the difference between the Natural gas rent(as % of GDP) of Azerbaijan in 1993 and the Natural gas rent(as % of GDP) of Georgia in 2000?
Your answer should be very brief. 8.59. What is the difference between the Natural gas rent(as % of GDP) of Azerbaijan in 1993 and the Natural gas rent(as % of GDP) of Israel in 2000?
Offer a terse response. 8.84. What is the difference between the Natural gas rent(as % of GDP) in Georgia in 1993 and the Natural gas rent(as % of GDP) in Israel in 2000?
Make the answer very short. 0.11. What is the difference between the Natural gas rent(as % of GDP) in South Asia in 1994 and the Natural gas rent(as % of GDP) in Azerbaijan in 1995?
Ensure brevity in your answer.  -9.57. What is the difference between the Natural gas rent(as % of GDP) of South Asia in 1994 and the Natural gas rent(as % of GDP) of Georgia in 1995?
Offer a terse response. 0.45. What is the difference between the Natural gas rent(as % of GDP) in South Asia in 1994 and the Natural gas rent(as % of GDP) in Israel in 1995?
Your answer should be very brief. 0.47. What is the difference between the Natural gas rent(as % of GDP) in Azerbaijan in 1994 and the Natural gas rent(as % of GDP) in Georgia in 1995?
Provide a succinct answer. 8.76. What is the difference between the Natural gas rent(as % of GDP) of Azerbaijan in 1994 and the Natural gas rent(as % of GDP) of Israel in 1995?
Ensure brevity in your answer.  8.78. What is the difference between the Natural gas rent(as % of GDP) of Georgia in 1994 and the Natural gas rent(as % of GDP) of Israel in 1995?
Make the answer very short. 0. What is the difference between the Natural gas rent(as % of GDP) in South Asia in 1994 and the Natural gas rent(as % of GDP) in Azerbaijan in 1996?
Provide a short and direct response. -12.27. What is the difference between the Natural gas rent(as % of GDP) in South Asia in 1994 and the Natural gas rent(as % of GDP) in Georgia in 1996?
Ensure brevity in your answer.  0.46. What is the difference between the Natural gas rent(as % of GDP) in South Asia in 1994 and the Natural gas rent(as % of GDP) in Israel in 1996?
Provide a short and direct response. 0.47. What is the difference between the Natural gas rent(as % of GDP) of Azerbaijan in 1994 and the Natural gas rent(as % of GDP) of Georgia in 1996?
Your answer should be compact. 8.77. What is the difference between the Natural gas rent(as % of GDP) of Azerbaijan in 1994 and the Natural gas rent(as % of GDP) of Israel in 1996?
Provide a succinct answer. 8.78. What is the difference between the Natural gas rent(as % of GDP) in Georgia in 1994 and the Natural gas rent(as % of GDP) in Israel in 1996?
Make the answer very short. 0. What is the difference between the Natural gas rent(as % of GDP) of South Asia in 1994 and the Natural gas rent(as % of GDP) of Azerbaijan in 2000?
Your answer should be compact. -10.2. What is the difference between the Natural gas rent(as % of GDP) of South Asia in 1994 and the Natural gas rent(as % of GDP) of Georgia in 2000?
Your response must be concise. 0.22. What is the difference between the Natural gas rent(as % of GDP) of South Asia in 1994 and the Natural gas rent(as % of GDP) of Israel in 2000?
Ensure brevity in your answer.  0.47. What is the difference between the Natural gas rent(as % of GDP) in Azerbaijan in 1994 and the Natural gas rent(as % of GDP) in Georgia in 2000?
Make the answer very short. 8.53. What is the difference between the Natural gas rent(as % of GDP) of Azerbaijan in 1994 and the Natural gas rent(as % of GDP) of Israel in 2000?
Provide a short and direct response. 8.78. What is the difference between the Natural gas rent(as % of GDP) in Georgia in 1994 and the Natural gas rent(as % of GDP) in Israel in 2000?
Give a very brief answer. 0. What is the difference between the Natural gas rent(as % of GDP) of South Asia in 1995 and the Natural gas rent(as % of GDP) of Azerbaijan in 1996?
Your answer should be very brief. -12.27. What is the difference between the Natural gas rent(as % of GDP) in South Asia in 1995 and the Natural gas rent(as % of GDP) in Georgia in 1996?
Offer a very short reply. 0.46. What is the difference between the Natural gas rent(as % of GDP) in South Asia in 1995 and the Natural gas rent(as % of GDP) in Israel in 1996?
Provide a short and direct response. 0.47. What is the difference between the Natural gas rent(as % of GDP) of Azerbaijan in 1995 and the Natural gas rent(as % of GDP) of Georgia in 1996?
Your response must be concise. 10.04. What is the difference between the Natural gas rent(as % of GDP) in Azerbaijan in 1995 and the Natural gas rent(as % of GDP) in Israel in 1996?
Ensure brevity in your answer.  10.04. What is the difference between the Natural gas rent(as % of GDP) of Georgia in 1995 and the Natural gas rent(as % of GDP) of Israel in 1996?
Offer a terse response. 0.02. What is the difference between the Natural gas rent(as % of GDP) in South Asia in 1995 and the Natural gas rent(as % of GDP) in Azerbaijan in 2000?
Provide a short and direct response. -10.2. What is the difference between the Natural gas rent(as % of GDP) in South Asia in 1995 and the Natural gas rent(as % of GDP) in Georgia in 2000?
Keep it short and to the point. 0.22. What is the difference between the Natural gas rent(as % of GDP) in South Asia in 1995 and the Natural gas rent(as % of GDP) in Israel in 2000?
Offer a very short reply. 0.47. What is the difference between the Natural gas rent(as % of GDP) of Azerbaijan in 1995 and the Natural gas rent(as % of GDP) of Georgia in 2000?
Provide a short and direct response. 9.8. What is the difference between the Natural gas rent(as % of GDP) of Azerbaijan in 1995 and the Natural gas rent(as % of GDP) of Israel in 2000?
Offer a very short reply. 10.04. What is the difference between the Natural gas rent(as % of GDP) in Georgia in 1995 and the Natural gas rent(as % of GDP) in Israel in 2000?
Offer a terse response. 0.02. What is the difference between the Natural gas rent(as % of GDP) in South Asia in 1996 and the Natural gas rent(as % of GDP) in Azerbaijan in 2000?
Ensure brevity in your answer.  -10.04. What is the difference between the Natural gas rent(as % of GDP) in South Asia in 1996 and the Natural gas rent(as % of GDP) in Georgia in 2000?
Ensure brevity in your answer.  0.38. What is the difference between the Natural gas rent(as % of GDP) in South Asia in 1996 and the Natural gas rent(as % of GDP) in Israel in 2000?
Provide a short and direct response. 0.63. What is the difference between the Natural gas rent(as % of GDP) of Azerbaijan in 1996 and the Natural gas rent(as % of GDP) of Georgia in 2000?
Provide a succinct answer. 12.49. What is the difference between the Natural gas rent(as % of GDP) of Azerbaijan in 1996 and the Natural gas rent(as % of GDP) of Israel in 2000?
Give a very brief answer. 12.74. What is the difference between the Natural gas rent(as % of GDP) of Georgia in 1996 and the Natural gas rent(as % of GDP) of Israel in 2000?
Offer a terse response. 0.01. What is the average Natural gas rent(as % of GDP) of South Asia per year?
Your answer should be very brief. 0.56. What is the average Natural gas rent(as % of GDP) in Azerbaijan per year?
Offer a very short reply. 8.48. What is the average Natural gas rent(as % of GDP) of Georgia per year?
Your answer should be very brief. 0.07. What is the average Natural gas rent(as % of GDP) of Israel per year?
Give a very brief answer. 0. In the year 1990, what is the difference between the Natural gas rent(as % of GDP) of South Asia and Natural gas rent(as % of GDP) of Azerbaijan?
Offer a terse response. -4.93. In the year 1990, what is the difference between the Natural gas rent(as % of GDP) of South Asia and Natural gas rent(as % of GDP) of Georgia?
Keep it short and to the point. 0.35. In the year 1990, what is the difference between the Natural gas rent(as % of GDP) of South Asia and Natural gas rent(as % of GDP) of Israel?
Ensure brevity in your answer.  0.39. In the year 1990, what is the difference between the Natural gas rent(as % of GDP) in Azerbaijan and Natural gas rent(as % of GDP) in Georgia?
Your answer should be very brief. 5.28. In the year 1990, what is the difference between the Natural gas rent(as % of GDP) of Azerbaijan and Natural gas rent(as % of GDP) of Israel?
Provide a succinct answer. 5.32. In the year 1990, what is the difference between the Natural gas rent(as % of GDP) of Georgia and Natural gas rent(as % of GDP) of Israel?
Keep it short and to the point. 0.04. In the year 1991, what is the difference between the Natural gas rent(as % of GDP) in South Asia and Natural gas rent(as % of GDP) in Azerbaijan?
Offer a terse response. -4.24. In the year 1991, what is the difference between the Natural gas rent(as % of GDP) in South Asia and Natural gas rent(as % of GDP) in Georgia?
Offer a very short reply. 0.44. In the year 1991, what is the difference between the Natural gas rent(as % of GDP) in South Asia and Natural gas rent(as % of GDP) in Israel?
Provide a succinct answer. 0.49. In the year 1991, what is the difference between the Natural gas rent(as % of GDP) in Azerbaijan and Natural gas rent(as % of GDP) in Georgia?
Your answer should be compact. 4.68. In the year 1991, what is the difference between the Natural gas rent(as % of GDP) of Azerbaijan and Natural gas rent(as % of GDP) of Israel?
Your response must be concise. 4.73. In the year 1991, what is the difference between the Natural gas rent(as % of GDP) of Georgia and Natural gas rent(as % of GDP) of Israel?
Your answer should be very brief. 0.05. In the year 1992, what is the difference between the Natural gas rent(as % of GDP) in South Asia and Natural gas rent(as % of GDP) in Azerbaijan?
Offer a very short reply. -6.29. In the year 1992, what is the difference between the Natural gas rent(as % of GDP) in South Asia and Natural gas rent(as % of GDP) in Georgia?
Your answer should be compact. 0.37. In the year 1992, what is the difference between the Natural gas rent(as % of GDP) in South Asia and Natural gas rent(as % of GDP) in Israel?
Offer a terse response. 0.44. In the year 1992, what is the difference between the Natural gas rent(as % of GDP) of Azerbaijan and Natural gas rent(as % of GDP) of Georgia?
Offer a terse response. 6.67. In the year 1992, what is the difference between the Natural gas rent(as % of GDP) in Azerbaijan and Natural gas rent(as % of GDP) in Israel?
Offer a terse response. 6.73. In the year 1992, what is the difference between the Natural gas rent(as % of GDP) of Georgia and Natural gas rent(as % of GDP) of Israel?
Provide a short and direct response. 0.06. In the year 1993, what is the difference between the Natural gas rent(as % of GDP) in South Asia and Natural gas rent(as % of GDP) in Azerbaijan?
Offer a terse response. -8.27. In the year 1993, what is the difference between the Natural gas rent(as % of GDP) in South Asia and Natural gas rent(as % of GDP) in Georgia?
Provide a short and direct response. 0.46. In the year 1993, what is the difference between the Natural gas rent(as % of GDP) in South Asia and Natural gas rent(as % of GDP) in Israel?
Your answer should be compact. 0.57. In the year 1993, what is the difference between the Natural gas rent(as % of GDP) in Azerbaijan and Natural gas rent(as % of GDP) in Georgia?
Your answer should be compact. 8.74. In the year 1993, what is the difference between the Natural gas rent(as % of GDP) in Azerbaijan and Natural gas rent(as % of GDP) in Israel?
Offer a terse response. 8.84. In the year 1993, what is the difference between the Natural gas rent(as % of GDP) in Georgia and Natural gas rent(as % of GDP) in Israel?
Offer a very short reply. 0.1. In the year 1994, what is the difference between the Natural gas rent(as % of GDP) of South Asia and Natural gas rent(as % of GDP) of Azerbaijan?
Make the answer very short. -8.31. In the year 1994, what is the difference between the Natural gas rent(as % of GDP) of South Asia and Natural gas rent(as % of GDP) of Georgia?
Offer a very short reply. 0.46. In the year 1994, what is the difference between the Natural gas rent(as % of GDP) of South Asia and Natural gas rent(as % of GDP) of Israel?
Offer a terse response. 0.47. In the year 1994, what is the difference between the Natural gas rent(as % of GDP) in Azerbaijan and Natural gas rent(as % of GDP) in Georgia?
Give a very brief answer. 8.78. In the year 1994, what is the difference between the Natural gas rent(as % of GDP) in Azerbaijan and Natural gas rent(as % of GDP) in Israel?
Your response must be concise. 8.78. In the year 1994, what is the difference between the Natural gas rent(as % of GDP) of Georgia and Natural gas rent(as % of GDP) of Israel?
Offer a terse response. 0. In the year 1995, what is the difference between the Natural gas rent(as % of GDP) of South Asia and Natural gas rent(as % of GDP) of Azerbaijan?
Offer a very short reply. -9.57. In the year 1995, what is the difference between the Natural gas rent(as % of GDP) of South Asia and Natural gas rent(as % of GDP) of Georgia?
Ensure brevity in your answer.  0.45. In the year 1995, what is the difference between the Natural gas rent(as % of GDP) of South Asia and Natural gas rent(as % of GDP) of Israel?
Ensure brevity in your answer.  0.47. In the year 1995, what is the difference between the Natural gas rent(as % of GDP) of Azerbaijan and Natural gas rent(as % of GDP) of Georgia?
Provide a short and direct response. 10.02. In the year 1995, what is the difference between the Natural gas rent(as % of GDP) of Azerbaijan and Natural gas rent(as % of GDP) of Israel?
Provide a succinct answer. 10.04. In the year 1995, what is the difference between the Natural gas rent(as % of GDP) of Georgia and Natural gas rent(as % of GDP) of Israel?
Give a very brief answer. 0.02. In the year 1996, what is the difference between the Natural gas rent(as % of GDP) in South Asia and Natural gas rent(as % of GDP) in Azerbaijan?
Your response must be concise. -12.11. In the year 1996, what is the difference between the Natural gas rent(as % of GDP) in South Asia and Natural gas rent(as % of GDP) in Georgia?
Offer a terse response. 0.62. In the year 1996, what is the difference between the Natural gas rent(as % of GDP) of South Asia and Natural gas rent(as % of GDP) of Israel?
Provide a succinct answer. 0.63. In the year 1996, what is the difference between the Natural gas rent(as % of GDP) in Azerbaijan and Natural gas rent(as % of GDP) in Georgia?
Your answer should be very brief. 12.73. In the year 1996, what is the difference between the Natural gas rent(as % of GDP) of Azerbaijan and Natural gas rent(as % of GDP) of Israel?
Your answer should be very brief. 12.74. In the year 1996, what is the difference between the Natural gas rent(as % of GDP) in Georgia and Natural gas rent(as % of GDP) in Israel?
Your answer should be very brief. 0.01. In the year 2000, what is the difference between the Natural gas rent(as % of GDP) in South Asia and Natural gas rent(as % of GDP) in Azerbaijan?
Provide a short and direct response. -9.62. In the year 2000, what is the difference between the Natural gas rent(as % of GDP) in South Asia and Natural gas rent(as % of GDP) in Georgia?
Give a very brief answer. 0.8. In the year 2000, what is the difference between the Natural gas rent(as % of GDP) of South Asia and Natural gas rent(as % of GDP) of Israel?
Provide a succinct answer. 1.05. In the year 2000, what is the difference between the Natural gas rent(as % of GDP) in Azerbaijan and Natural gas rent(as % of GDP) in Georgia?
Your answer should be very brief. 10.42. In the year 2000, what is the difference between the Natural gas rent(as % of GDP) of Azerbaijan and Natural gas rent(as % of GDP) of Israel?
Give a very brief answer. 10.67. In the year 2000, what is the difference between the Natural gas rent(as % of GDP) in Georgia and Natural gas rent(as % of GDP) in Israel?
Your response must be concise. 0.25. What is the ratio of the Natural gas rent(as % of GDP) in South Asia in 1990 to that in 1991?
Your response must be concise. 0.8. What is the ratio of the Natural gas rent(as % of GDP) of Georgia in 1990 to that in 1991?
Keep it short and to the point. 0.81. What is the ratio of the Natural gas rent(as % of GDP) in Israel in 1990 to that in 1991?
Keep it short and to the point. 1.51. What is the ratio of the Natural gas rent(as % of GDP) in South Asia in 1990 to that in 1992?
Keep it short and to the point. 0.9. What is the ratio of the Natural gas rent(as % of GDP) of Azerbaijan in 1990 to that in 1992?
Ensure brevity in your answer.  0.79. What is the ratio of the Natural gas rent(as % of GDP) of Georgia in 1990 to that in 1992?
Provide a succinct answer. 0.64. What is the ratio of the Natural gas rent(as % of GDP) in Israel in 1990 to that in 1992?
Make the answer very short. 1.9. What is the ratio of the Natural gas rent(as % of GDP) of South Asia in 1990 to that in 1993?
Give a very brief answer. 0.69. What is the ratio of the Natural gas rent(as % of GDP) in Azerbaijan in 1990 to that in 1993?
Make the answer very short. 0.6. What is the ratio of the Natural gas rent(as % of GDP) of Georgia in 1990 to that in 1993?
Your answer should be compact. 0.39. What is the ratio of the Natural gas rent(as % of GDP) of Israel in 1990 to that in 1993?
Provide a short and direct response. 1.53. What is the ratio of the Natural gas rent(as % of GDP) in South Asia in 1990 to that in 1994?
Your answer should be compact. 0.84. What is the ratio of the Natural gas rent(as % of GDP) of Azerbaijan in 1990 to that in 1994?
Make the answer very short. 0.61. What is the ratio of the Natural gas rent(as % of GDP) of Georgia in 1990 to that in 1994?
Offer a terse response. 7.77. What is the ratio of the Natural gas rent(as % of GDP) in Israel in 1990 to that in 1994?
Keep it short and to the point. 2.16. What is the ratio of the Natural gas rent(as % of GDP) in South Asia in 1990 to that in 1995?
Keep it short and to the point. 0.84. What is the ratio of the Natural gas rent(as % of GDP) of Azerbaijan in 1990 to that in 1995?
Your response must be concise. 0.53. What is the ratio of the Natural gas rent(as % of GDP) of Georgia in 1990 to that in 1995?
Provide a short and direct response. 2.04. What is the ratio of the Natural gas rent(as % of GDP) in Israel in 1990 to that in 1995?
Your response must be concise. 2.82. What is the ratio of the Natural gas rent(as % of GDP) of South Asia in 1990 to that in 1996?
Offer a terse response. 0.63. What is the ratio of the Natural gas rent(as % of GDP) in Azerbaijan in 1990 to that in 1996?
Keep it short and to the point. 0.42. What is the ratio of the Natural gas rent(as % of GDP) in Georgia in 1990 to that in 1996?
Offer a terse response. 5.37. What is the ratio of the Natural gas rent(as % of GDP) in Israel in 1990 to that in 1996?
Your answer should be very brief. 3.64. What is the ratio of the Natural gas rent(as % of GDP) of South Asia in 1990 to that in 2000?
Offer a very short reply. 0.38. What is the ratio of the Natural gas rent(as % of GDP) in Azerbaijan in 1990 to that in 2000?
Provide a succinct answer. 0.5. What is the ratio of the Natural gas rent(as % of GDP) in Georgia in 1990 to that in 2000?
Offer a very short reply. 0.17. What is the ratio of the Natural gas rent(as % of GDP) in Israel in 1990 to that in 2000?
Give a very brief answer. 4.51. What is the ratio of the Natural gas rent(as % of GDP) in South Asia in 1991 to that in 1992?
Provide a succinct answer. 1.13. What is the ratio of the Natural gas rent(as % of GDP) in Azerbaijan in 1991 to that in 1992?
Your answer should be very brief. 0.7. What is the ratio of the Natural gas rent(as % of GDP) of Georgia in 1991 to that in 1992?
Keep it short and to the point. 0.8. What is the ratio of the Natural gas rent(as % of GDP) in Israel in 1991 to that in 1992?
Offer a very short reply. 1.26. What is the ratio of the Natural gas rent(as % of GDP) of South Asia in 1991 to that in 1993?
Your answer should be very brief. 0.87. What is the ratio of the Natural gas rent(as % of GDP) in Azerbaijan in 1991 to that in 1993?
Your answer should be compact. 0.54. What is the ratio of the Natural gas rent(as % of GDP) of Georgia in 1991 to that in 1993?
Offer a terse response. 0.48. What is the ratio of the Natural gas rent(as % of GDP) of Israel in 1991 to that in 1993?
Your response must be concise. 1.01. What is the ratio of the Natural gas rent(as % of GDP) in South Asia in 1991 to that in 1994?
Provide a short and direct response. 1.06. What is the ratio of the Natural gas rent(as % of GDP) of Azerbaijan in 1991 to that in 1994?
Offer a terse response. 0.54. What is the ratio of the Natural gas rent(as % of GDP) in Georgia in 1991 to that in 1994?
Give a very brief answer. 9.65. What is the ratio of the Natural gas rent(as % of GDP) of Israel in 1991 to that in 1994?
Your answer should be very brief. 1.43. What is the ratio of the Natural gas rent(as % of GDP) in South Asia in 1991 to that in 1995?
Your response must be concise. 1.05. What is the ratio of the Natural gas rent(as % of GDP) in Azerbaijan in 1991 to that in 1995?
Your answer should be very brief. 0.47. What is the ratio of the Natural gas rent(as % of GDP) of Georgia in 1991 to that in 1995?
Ensure brevity in your answer.  2.54. What is the ratio of the Natural gas rent(as % of GDP) of Israel in 1991 to that in 1995?
Keep it short and to the point. 1.87. What is the ratio of the Natural gas rent(as % of GDP) in South Asia in 1991 to that in 1996?
Give a very brief answer. 0.78. What is the ratio of the Natural gas rent(as % of GDP) in Azerbaijan in 1991 to that in 1996?
Keep it short and to the point. 0.37. What is the ratio of the Natural gas rent(as % of GDP) of Georgia in 1991 to that in 1996?
Provide a short and direct response. 6.67. What is the ratio of the Natural gas rent(as % of GDP) in Israel in 1991 to that in 1996?
Give a very brief answer. 2.41. What is the ratio of the Natural gas rent(as % of GDP) of South Asia in 1991 to that in 2000?
Keep it short and to the point. 0.47. What is the ratio of the Natural gas rent(as % of GDP) of Azerbaijan in 1991 to that in 2000?
Your response must be concise. 0.44. What is the ratio of the Natural gas rent(as % of GDP) in Georgia in 1991 to that in 2000?
Your response must be concise. 0.21. What is the ratio of the Natural gas rent(as % of GDP) of Israel in 1991 to that in 2000?
Ensure brevity in your answer.  2.99. What is the ratio of the Natural gas rent(as % of GDP) of South Asia in 1992 to that in 1993?
Offer a terse response. 0.77. What is the ratio of the Natural gas rent(as % of GDP) in Azerbaijan in 1992 to that in 1993?
Provide a succinct answer. 0.76. What is the ratio of the Natural gas rent(as % of GDP) in Georgia in 1992 to that in 1993?
Your response must be concise. 0.6. What is the ratio of the Natural gas rent(as % of GDP) in Israel in 1992 to that in 1993?
Your answer should be compact. 0.81. What is the ratio of the Natural gas rent(as % of GDP) of South Asia in 1992 to that in 1994?
Your response must be concise. 0.93. What is the ratio of the Natural gas rent(as % of GDP) in Azerbaijan in 1992 to that in 1994?
Offer a very short reply. 0.77. What is the ratio of the Natural gas rent(as % of GDP) of Georgia in 1992 to that in 1994?
Offer a very short reply. 12.07. What is the ratio of the Natural gas rent(as % of GDP) in Israel in 1992 to that in 1994?
Provide a short and direct response. 1.14. What is the ratio of the Natural gas rent(as % of GDP) of South Asia in 1992 to that in 1995?
Offer a terse response. 0.93. What is the ratio of the Natural gas rent(as % of GDP) of Azerbaijan in 1992 to that in 1995?
Give a very brief answer. 0.67. What is the ratio of the Natural gas rent(as % of GDP) in Georgia in 1992 to that in 1995?
Your answer should be compact. 3.17. What is the ratio of the Natural gas rent(as % of GDP) in Israel in 1992 to that in 1995?
Your answer should be compact. 1.49. What is the ratio of the Natural gas rent(as % of GDP) in South Asia in 1992 to that in 1996?
Ensure brevity in your answer.  0.69. What is the ratio of the Natural gas rent(as % of GDP) of Azerbaijan in 1992 to that in 1996?
Make the answer very short. 0.53. What is the ratio of the Natural gas rent(as % of GDP) of Georgia in 1992 to that in 1996?
Make the answer very short. 8.34. What is the ratio of the Natural gas rent(as % of GDP) in Israel in 1992 to that in 1996?
Provide a short and direct response. 1.92. What is the ratio of the Natural gas rent(as % of GDP) of South Asia in 1992 to that in 2000?
Provide a short and direct response. 0.42. What is the ratio of the Natural gas rent(as % of GDP) of Azerbaijan in 1992 to that in 2000?
Offer a terse response. 0.63. What is the ratio of the Natural gas rent(as % of GDP) in Georgia in 1992 to that in 2000?
Keep it short and to the point. 0.26. What is the ratio of the Natural gas rent(as % of GDP) in Israel in 1992 to that in 2000?
Ensure brevity in your answer.  2.38. What is the ratio of the Natural gas rent(as % of GDP) of South Asia in 1993 to that in 1994?
Your response must be concise. 1.22. What is the ratio of the Natural gas rent(as % of GDP) of Georgia in 1993 to that in 1994?
Give a very brief answer. 20.02. What is the ratio of the Natural gas rent(as % of GDP) of Israel in 1993 to that in 1994?
Your answer should be compact. 1.42. What is the ratio of the Natural gas rent(as % of GDP) in South Asia in 1993 to that in 1995?
Your answer should be very brief. 1.21. What is the ratio of the Natural gas rent(as % of GDP) of Azerbaijan in 1993 to that in 1995?
Keep it short and to the point. 0.88. What is the ratio of the Natural gas rent(as % of GDP) in Georgia in 1993 to that in 1995?
Your response must be concise. 5.26. What is the ratio of the Natural gas rent(as % of GDP) in Israel in 1993 to that in 1995?
Offer a terse response. 1.85. What is the ratio of the Natural gas rent(as % of GDP) of South Asia in 1993 to that in 1996?
Your answer should be compact. 0.9. What is the ratio of the Natural gas rent(as % of GDP) in Azerbaijan in 1993 to that in 1996?
Give a very brief answer. 0.69. What is the ratio of the Natural gas rent(as % of GDP) in Georgia in 1993 to that in 1996?
Your answer should be very brief. 13.85. What is the ratio of the Natural gas rent(as % of GDP) of Israel in 1993 to that in 1996?
Give a very brief answer. 2.39. What is the ratio of the Natural gas rent(as % of GDP) in South Asia in 1993 to that in 2000?
Provide a succinct answer. 0.54. What is the ratio of the Natural gas rent(as % of GDP) of Azerbaijan in 1993 to that in 2000?
Provide a short and direct response. 0.83. What is the ratio of the Natural gas rent(as % of GDP) of Georgia in 1993 to that in 2000?
Ensure brevity in your answer.  0.43. What is the ratio of the Natural gas rent(as % of GDP) of Israel in 1993 to that in 2000?
Offer a terse response. 2.95. What is the ratio of the Natural gas rent(as % of GDP) in Azerbaijan in 1994 to that in 1995?
Your response must be concise. 0.87. What is the ratio of the Natural gas rent(as % of GDP) of Georgia in 1994 to that in 1995?
Give a very brief answer. 0.26. What is the ratio of the Natural gas rent(as % of GDP) in Israel in 1994 to that in 1995?
Offer a very short reply. 1.3. What is the ratio of the Natural gas rent(as % of GDP) of South Asia in 1994 to that in 1996?
Provide a succinct answer. 0.74. What is the ratio of the Natural gas rent(as % of GDP) of Azerbaijan in 1994 to that in 1996?
Offer a terse response. 0.69. What is the ratio of the Natural gas rent(as % of GDP) of Georgia in 1994 to that in 1996?
Keep it short and to the point. 0.69. What is the ratio of the Natural gas rent(as % of GDP) of Israel in 1994 to that in 1996?
Make the answer very short. 1.68. What is the ratio of the Natural gas rent(as % of GDP) in South Asia in 1994 to that in 2000?
Your response must be concise. 0.45. What is the ratio of the Natural gas rent(as % of GDP) in Azerbaijan in 1994 to that in 2000?
Your response must be concise. 0.82. What is the ratio of the Natural gas rent(as % of GDP) in Georgia in 1994 to that in 2000?
Provide a succinct answer. 0.02. What is the ratio of the Natural gas rent(as % of GDP) of Israel in 1994 to that in 2000?
Offer a very short reply. 2.08. What is the ratio of the Natural gas rent(as % of GDP) of South Asia in 1995 to that in 1996?
Offer a terse response. 0.75. What is the ratio of the Natural gas rent(as % of GDP) of Azerbaijan in 1995 to that in 1996?
Your answer should be very brief. 0.79. What is the ratio of the Natural gas rent(as % of GDP) of Georgia in 1995 to that in 1996?
Provide a short and direct response. 2.63. What is the ratio of the Natural gas rent(as % of GDP) of Israel in 1995 to that in 1996?
Offer a terse response. 1.29. What is the ratio of the Natural gas rent(as % of GDP) in South Asia in 1995 to that in 2000?
Your response must be concise. 0.45. What is the ratio of the Natural gas rent(as % of GDP) of Georgia in 1995 to that in 2000?
Provide a short and direct response. 0.08. What is the ratio of the Natural gas rent(as % of GDP) of Israel in 1995 to that in 2000?
Offer a terse response. 1.6. What is the ratio of the Natural gas rent(as % of GDP) of South Asia in 1996 to that in 2000?
Your response must be concise. 0.6. What is the ratio of the Natural gas rent(as % of GDP) of Azerbaijan in 1996 to that in 2000?
Provide a short and direct response. 1.19. What is the ratio of the Natural gas rent(as % of GDP) of Georgia in 1996 to that in 2000?
Your answer should be compact. 0.03. What is the ratio of the Natural gas rent(as % of GDP) in Israel in 1996 to that in 2000?
Provide a short and direct response. 1.24. What is the difference between the highest and the second highest Natural gas rent(as % of GDP) in South Asia?
Keep it short and to the point. 0.42. What is the difference between the highest and the second highest Natural gas rent(as % of GDP) in Azerbaijan?
Provide a succinct answer. 2.07. What is the difference between the highest and the second highest Natural gas rent(as % of GDP) in Georgia?
Your answer should be compact. 0.14. What is the difference between the highest and the second highest Natural gas rent(as % of GDP) of Israel?
Give a very brief answer. 0. What is the difference between the highest and the lowest Natural gas rent(as % of GDP) in South Asia?
Provide a short and direct response. 0.66. What is the difference between the highest and the lowest Natural gas rent(as % of GDP) of Azerbaijan?
Your answer should be compact. 8.01. What is the difference between the highest and the lowest Natural gas rent(as % of GDP) in Georgia?
Provide a succinct answer. 0.24. What is the difference between the highest and the lowest Natural gas rent(as % of GDP) in Israel?
Your response must be concise. 0. 